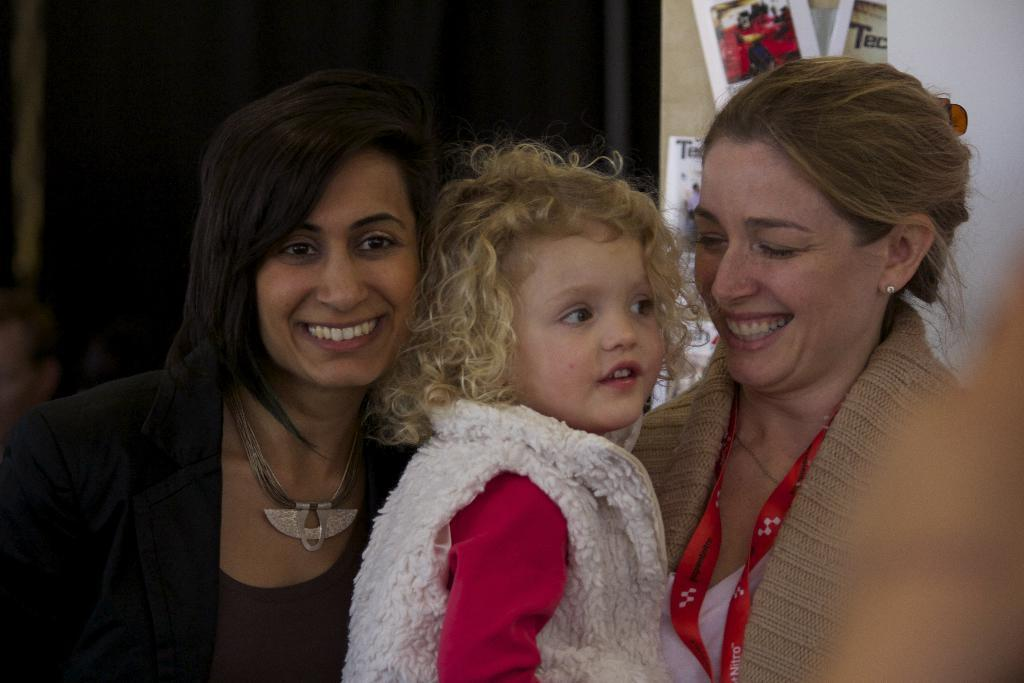What is happening with the persons in the center of the image? The persons in the center of the image are laughing. What can be seen in the background of the image? There is a curtain, boards, and a wall in the background of the image. Can you describe the setting of the image? The persons are in the center, and there are various background elements, including a curtain, boards, and a wall. What type of bomb can be seen in the image? There is no bomb present in the image. What is the thing that the persons are laughing at in the image? The provided facts do not mention any specific object or event that the persons are laughing at, so we cannot determine what they are laughing at from the image alone. 